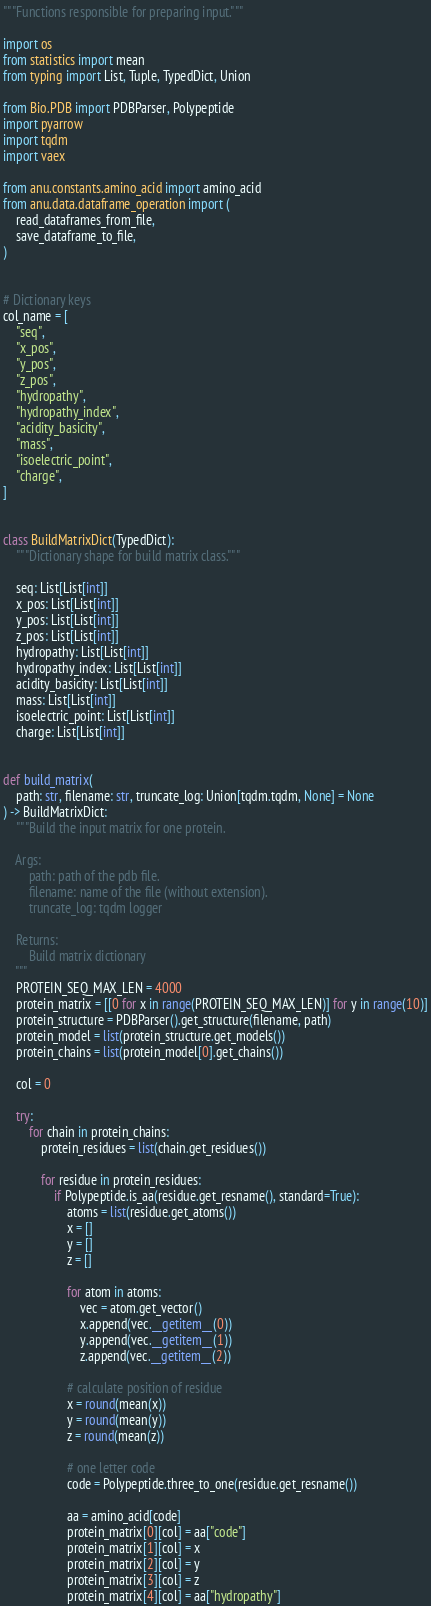<code> <loc_0><loc_0><loc_500><loc_500><_Python_>"""Functions responsible for preparing input."""

import os
from statistics import mean
from typing import List, Tuple, TypedDict, Union

from Bio.PDB import PDBParser, Polypeptide
import pyarrow
import tqdm
import vaex

from anu.constants.amino_acid import amino_acid
from anu.data.dataframe_operation import (
    read_dataframes_from_file,
    save_dataframe_to_file,
)


# Dictionary keys
col_name = [
    "seq",
    "x_pos",
    "y_pos",
    "z_pos",
    "hydropathy",
    "hydropathy_index",
    "acidity_basicity",
    "mass",
    "isoelectric_point",
    "charge",
]


class BuildMatrixDict(TypedDict):
    """Dictionary shape for build matrix class."""

    seq: List[List[int]]
    x_pos: List[List[int]]
    y_pos: List[List[int]]
    z_pos: List[List[int]]
    hydropathy: List[List[int]]
    hydropathy_index: List[List[int]]
    acidity_basicity: List[List[int]]
    mass: List[List[int]]
    isoelectric_point: List[List[int]]
    charge: List[List[int]]


def build_matrix(
    path: str, filename: str, truncate_log: Union[tqdm.tqdm, None] = None
) -> BuildMatrixDict:
    """Build the input matrix for one protein.

    Args:
        path: path of the pdb file.
        filename: name of the file (without extension).
        truncate_log: tqdm logger

    Returns:
        Build matrix dictionary
    """
    PROTEIN_SEQ_MAX_LEN = 4000
    protein_matrix = [[0 for x in range(PROTEIN_SEQ_MAX_LEN)] for y in range(10)]
    protein_structure = PDBParser().get_structure(filename, path)
    protein_model = list(protein_structure.get_models())
    protein_chains = list(protein_model[0].get_chains())

    col = 0

    try:
        for chain in protein_chains:
            protein_residues = list(chain.get_residues())

            for residue in protein_residues:
                if Polypeptide.is_aa(residue.get_resname(), standard=True):
                    atoms = list(residue.get_atoms())
                    x = []
                    y = []
                    z = []

                    for atom in atoms:
                        vec = atom.get_vector()
                        x.append(vec.__getitem__(0))
                        y.append(vec.__getitem__(1))
                        z.append(vec.__getitem__(2))

                    # calculate position of residue
                    x = round(mean(x))
                    y = round(mean(y))
                    z = round(mean(z))

                    # one letter code
                    code = Polypeptide.three_to_one(residue.get_resname())

                    aa = amino_acid[code]
                    protein_matrix[0][col] = aa["code"]
                    protein_matrix[1][col] = x
                    protein_matrix[2][col] = y
                    protein_matrix[3][col] = z
                    protein_matrix[4][col] = aa["hydropathy"]</code> 